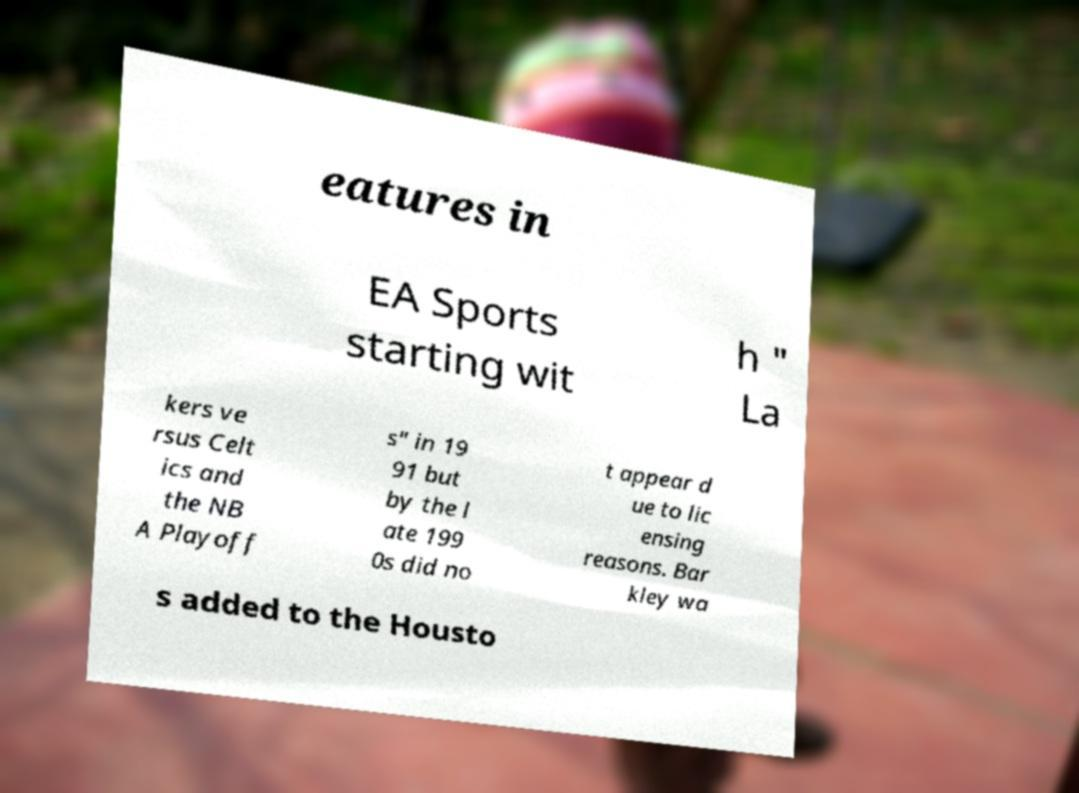Could you extract and type out the text from this image? eatures in EA Sports starting wit h " La kers ve rsus Celt ics and the NB A Playoff s" in 19 91 but by the l ate 199 0s did no t appear d ue to lic ensing reasons. Bar kley wa s added to the Housto 